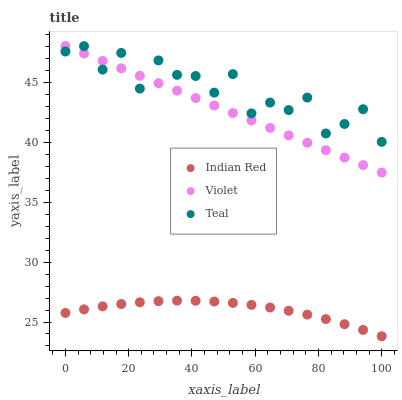Does Indian Red have the minimum area under the curve?
Answer yes or no. Yes. Does Teal have the maximum area under the curve?
Answer yes or no. Yes. Does Violet have the minimum area under the curve?
Answer yes or no. No. Does Violet have the maximum area under the curve?
Answer yes or no. No. Is Violet the smoothest?
Answer yes or no. Yes. Is Teal the roughest?
Answer yes or no. Yes. Is Indian Red the smoothest?
Answer yes or no. No. Is Indian Red the roughest?
Answer yes or no. No. Does Indian Red have the lowest value?
Answer yes or no. Yes. Does Violet have the lowest value?
Answer yes or no. No. Does Violet have the highest value?
Answer yes or no. Yes. Does Indian Red have the highest value?
Answer yes or no. No. Is Indian Red less than Teal?
Answer yes or no. Yes. Is Teal greater than Indian Red?
Answer yes or no. Yes. Does Violet intersect Teal?
Answer yes or no. Yes. Is Violet less than Teal?
Answer yes or no. No. Is Violet greater than Teal?
Answer yes or no. No. Does Indian Red intersect Teal?
Answer yes or no. No. 